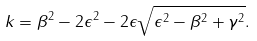Convert formula to latex. <formula><loc_0><loc_0><loc_500><loc_500>k = \beta ^ { 2 } - 2 \epsilon ^ { 2 } - 2 \epsilon \sqrt { \epsilon ^ { 2 } - \beta ^ { 2 } + \gamma ^ { 2 } } .</formula> 